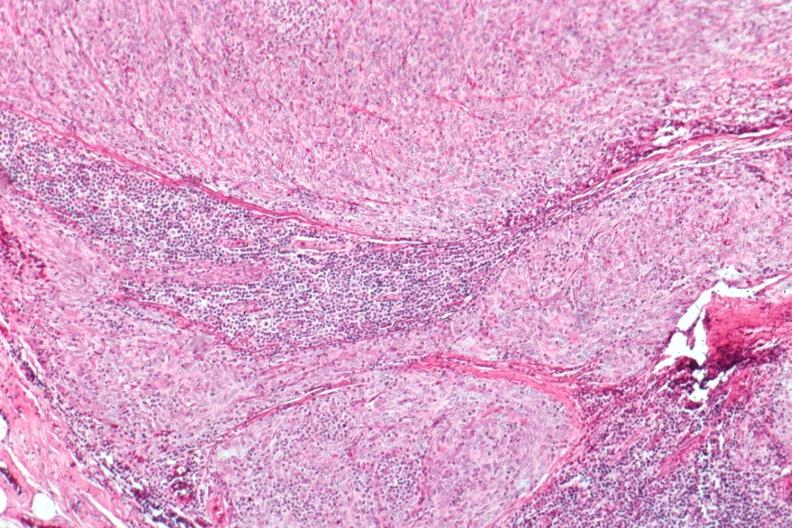s thymus present?
Answer the question using a single word or phrase. Yes 